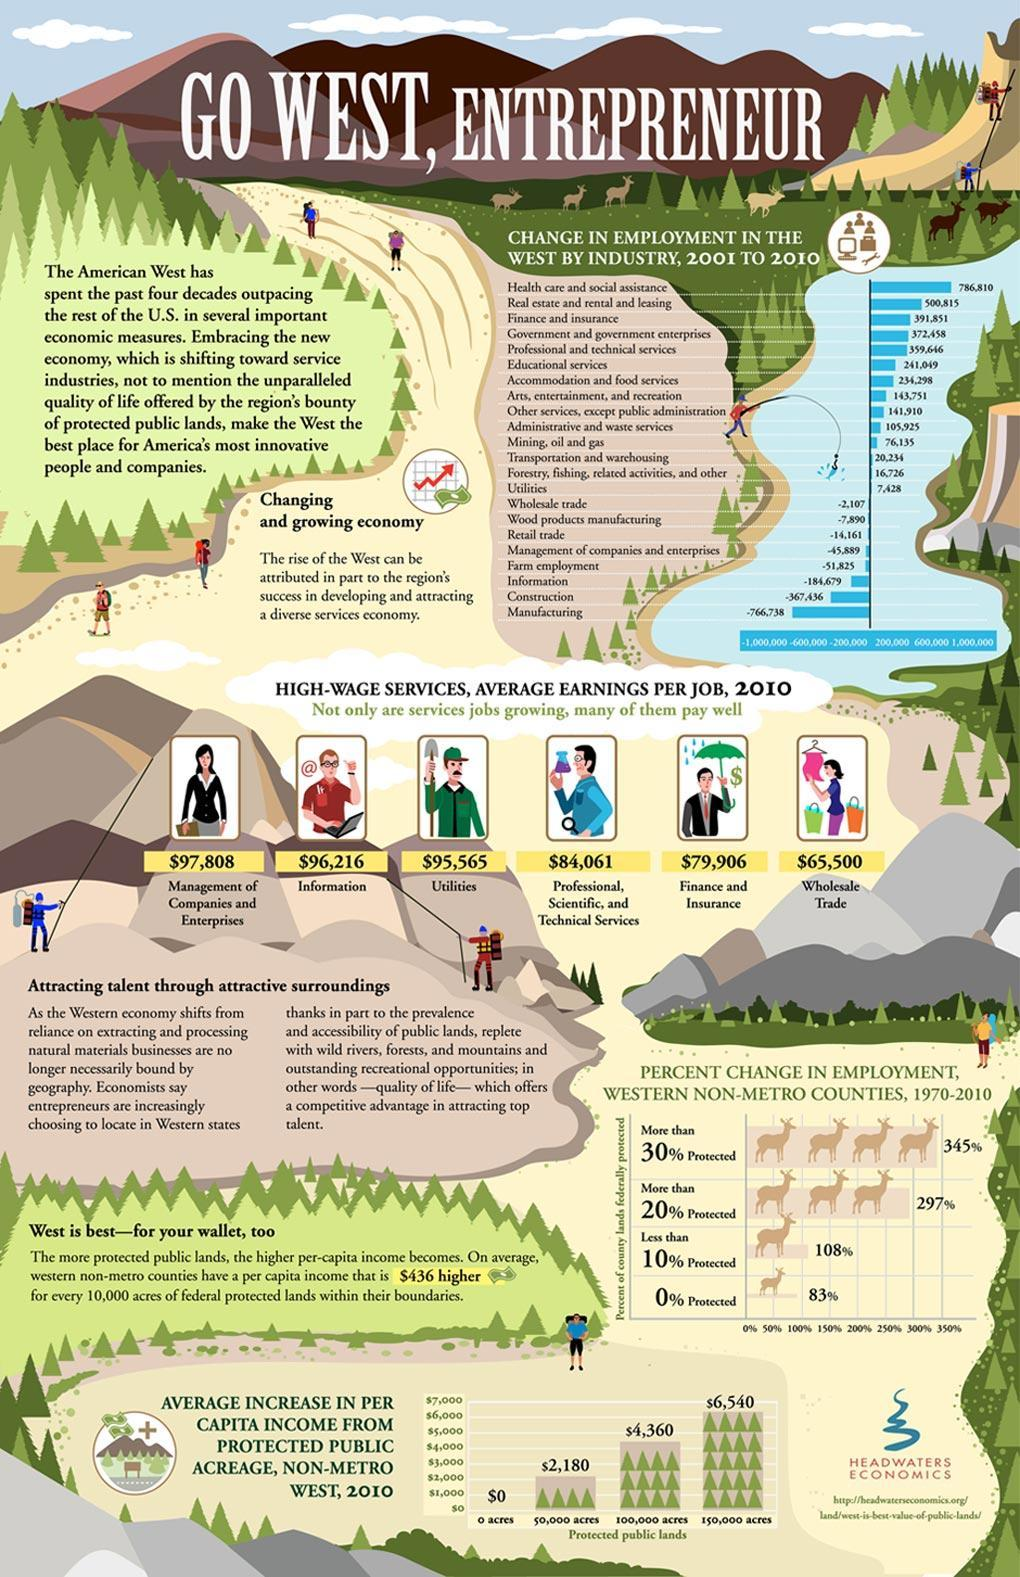What is the wage for utility services?
Answer the question with a short phrase. $95,565 What is the total wage for information and utility services? 191781 What is the wage for information services? $96,216 